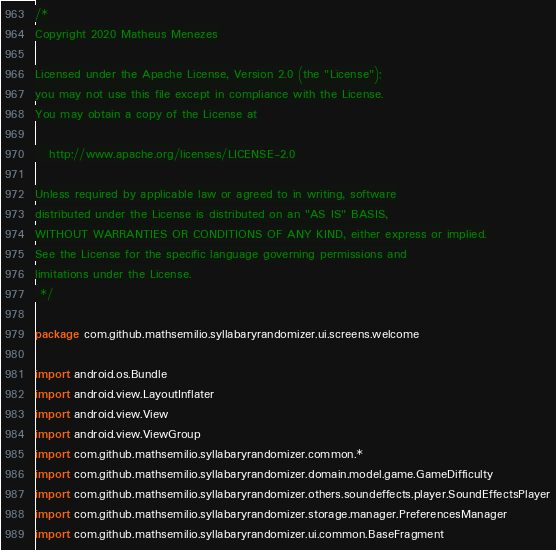<code> <loc_0><loc_0><loc_500><loc_500><_Kotlin_>/*
Copyright 2020 Matheus Menezes

Licensed under the Apache License, Version 2.0 (the "License");
you may not use this file except in compliance with the License.
You may obtain a copy of the License at

   http://www.apache.org/licenses/LICENSE-2.0

Unless required by applicable law or agreed to in writing, software
distributed under the License is distributed on an "AS IS" BASIS,
WITHOUT WARRANTIES OR CONDITIONS OF ANY KIND, either express or implied.
See the License for the specific language governing permissions and
limitations under the License.
 */

package com.github.mathsemilio.syllabaryrandomizer.ui.screens.welcome

import android.os.Bundle
import android.view.LayoutInflater
import android.view.View
import android.view.ViewGroup
import com.github.mathsemilio.syllabaryrandomizer.common.*
import com.github.mathsemilio.syllabaryrandomizer.domain.model.game.GameDifficulty
import com.github.mathsemilio.syllabaryrandomizer.others.soundeffects.player.SoundEffectsPlayer
import com.github.mathsemilio.syllabaryrandomizer.storage.manager.PreferencesManager
import com.github.mathsemilio.syllabaryrandomizer.ui.common.BaseFragment</code> 